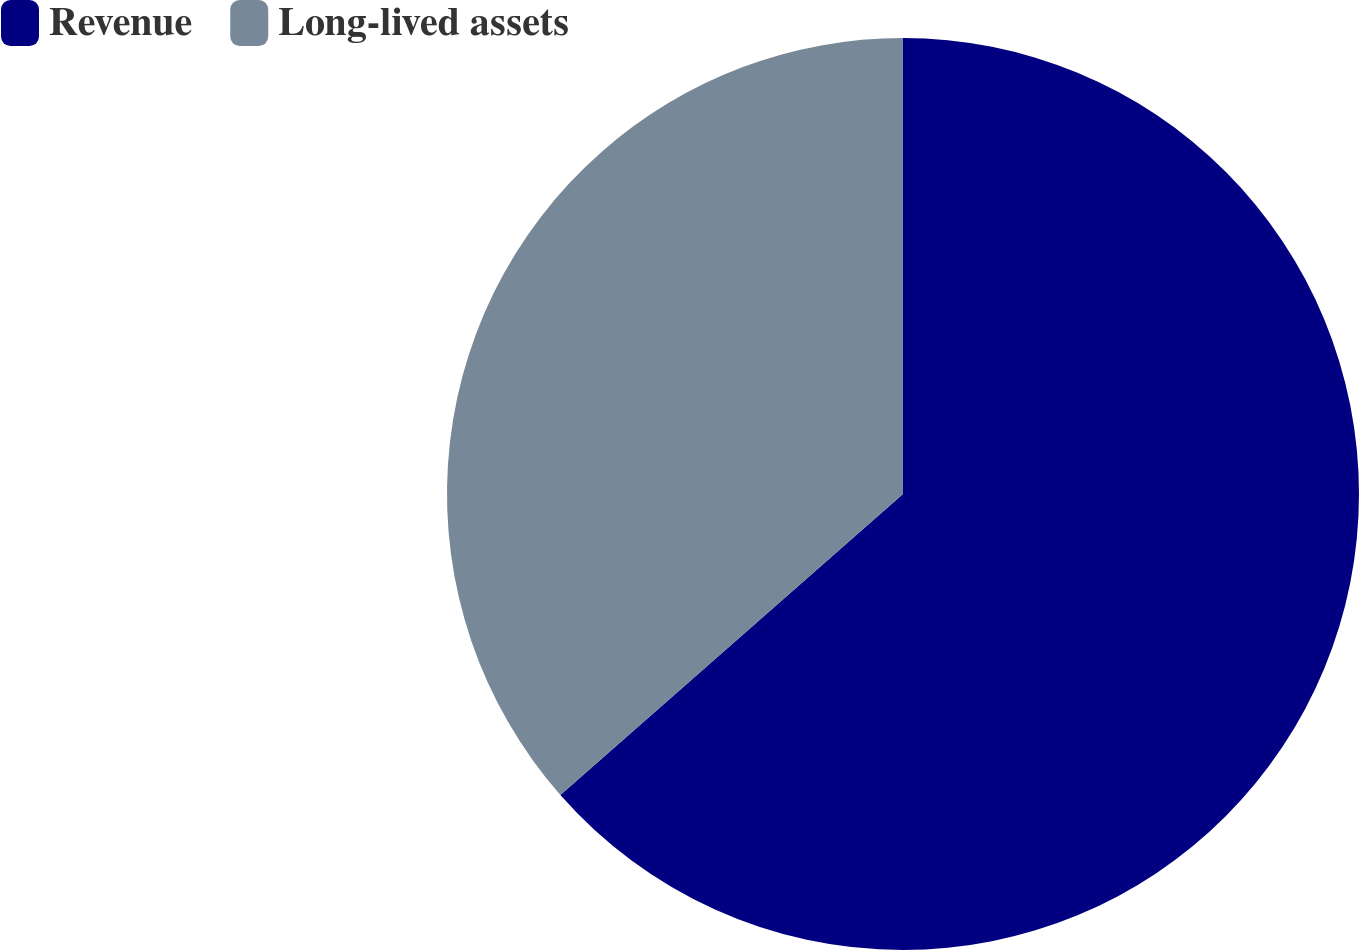Convert chart to OTSL. <chart><loc_0><loc_0><loc_500><loc_500><pie_chart><fcel>Revenue<fcel>Long-lived assets<nl><fcel>63.53%<fcel>36.47%<nl></chart> 